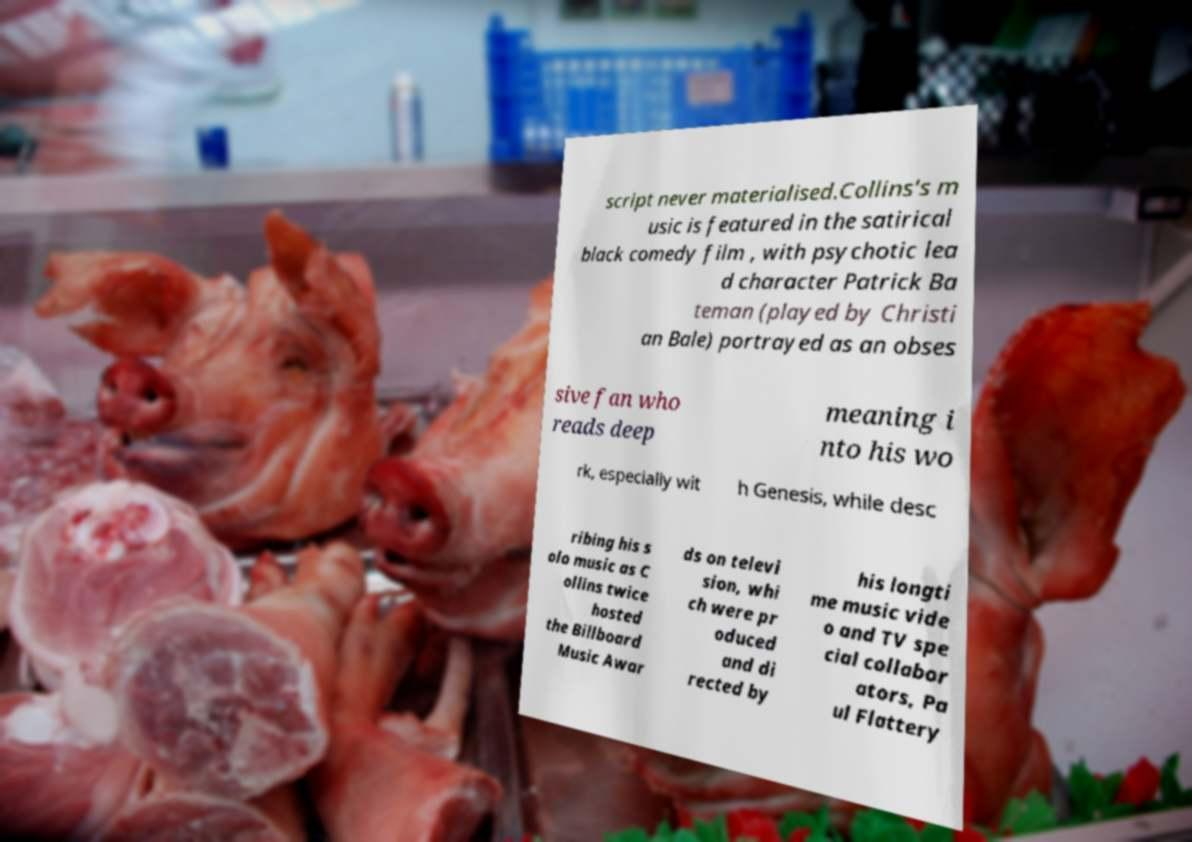Please identify and transcribe the text found in this image. script never materialised.Collins's m usic is featured in the satirical black comedy film , with psychotic lea d character Patrick Ba teman (played by Christi an Bale) portrayed as an obses sive fan who reads deep meaning i nto his wo rk, especially wit h Genesis, while desc ribing his s olo music as C ollins twice hosted the Billboard Music Awar ds on televi sion, whi ch were pr oduced and di rected by his longti me music vide o and TV spe cial collabor ators, Pa ul Flattery 